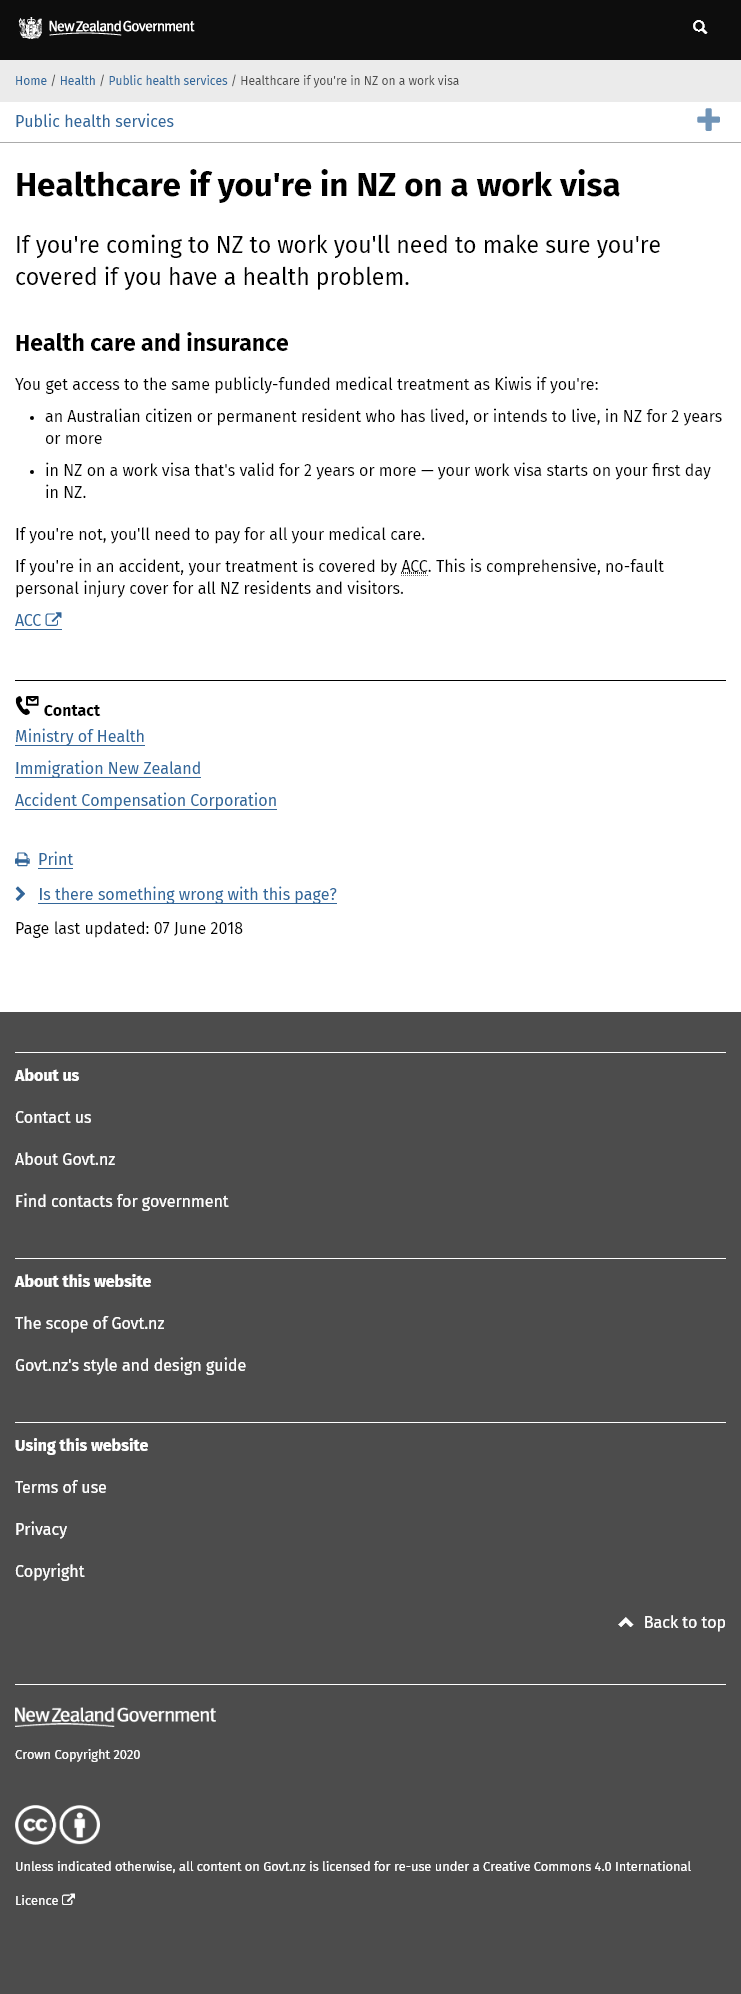Mention a couple of crucial points in this snapshot. To obtain access to medical treatment as a New Zealand resident, individuals must reside in the country for a minimum of two years. It is assured that in the event of a mishap, your treatment shall be protected by ACC. My work visa begins on the first day that I arrive in New Zealand. 